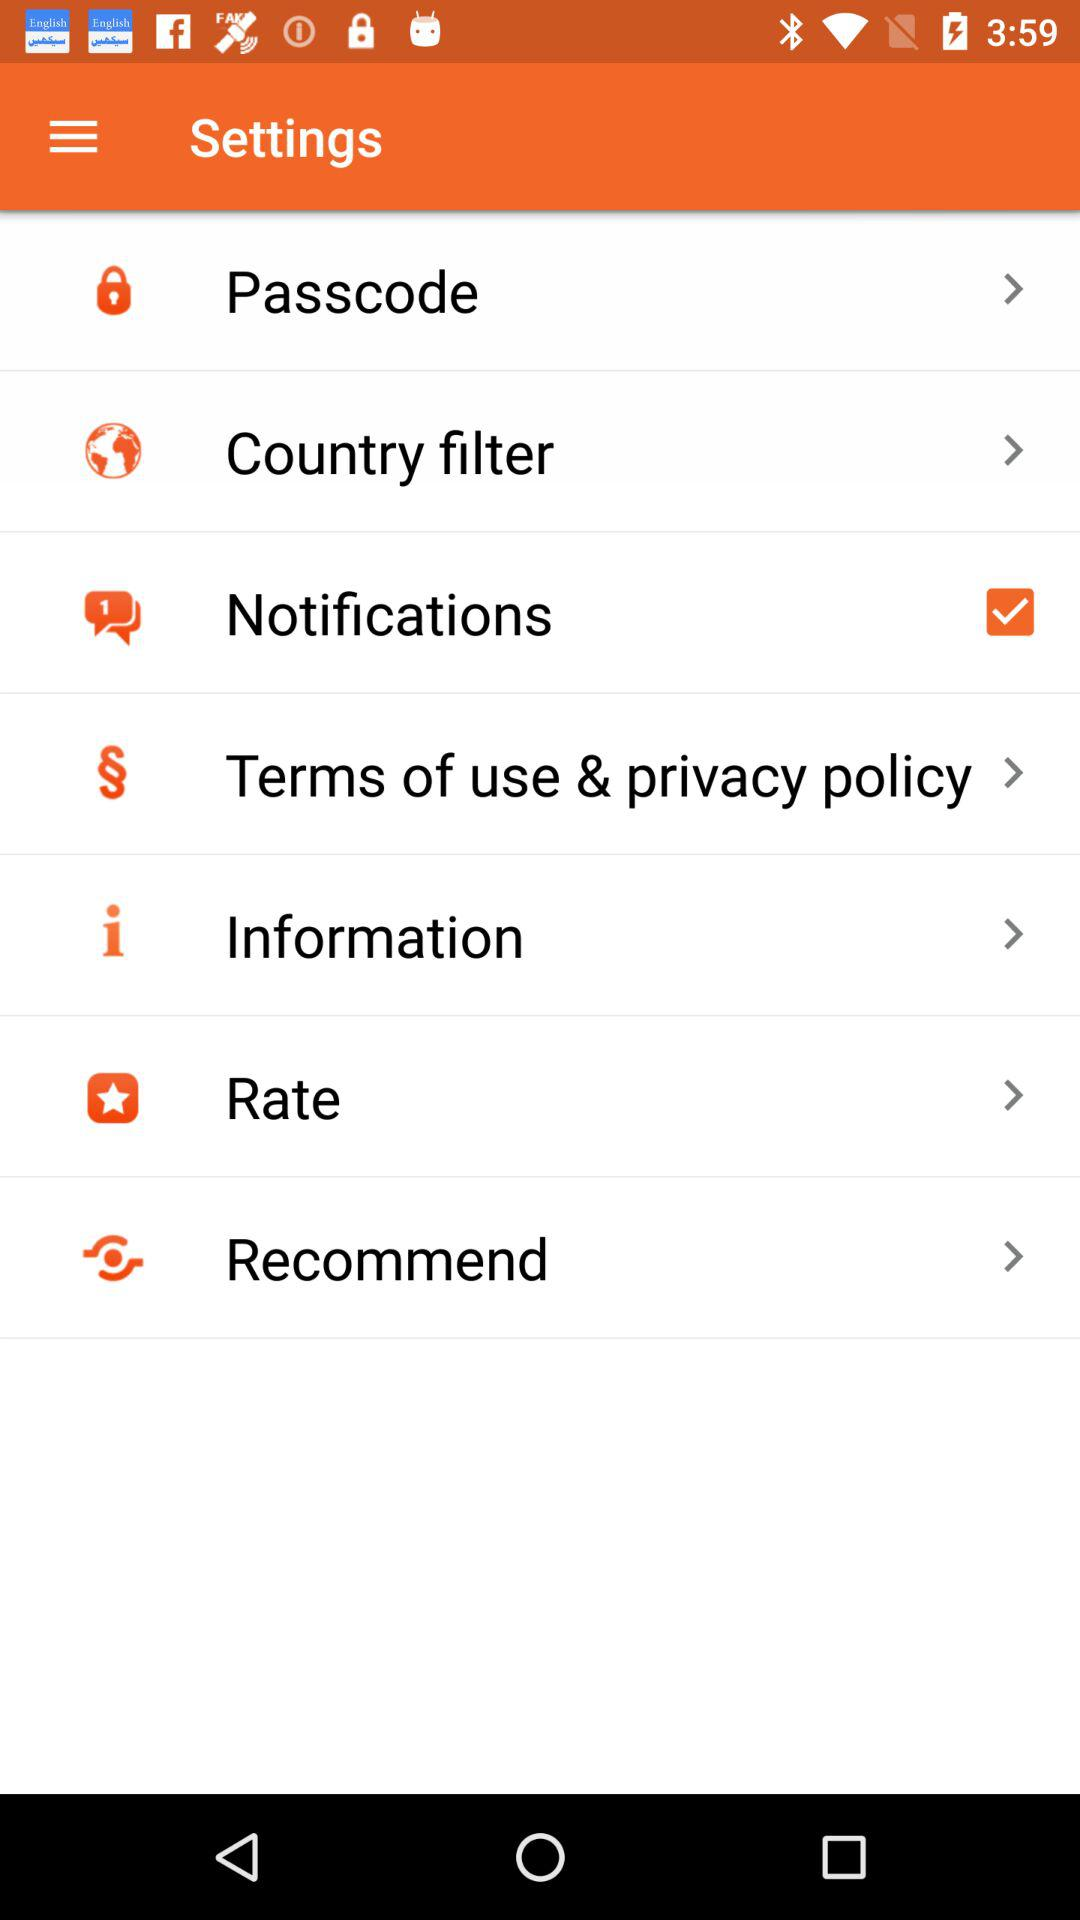How many stars is the application's rating?
When the provided information is insufficient, respond with <no answer>. <no answer> 